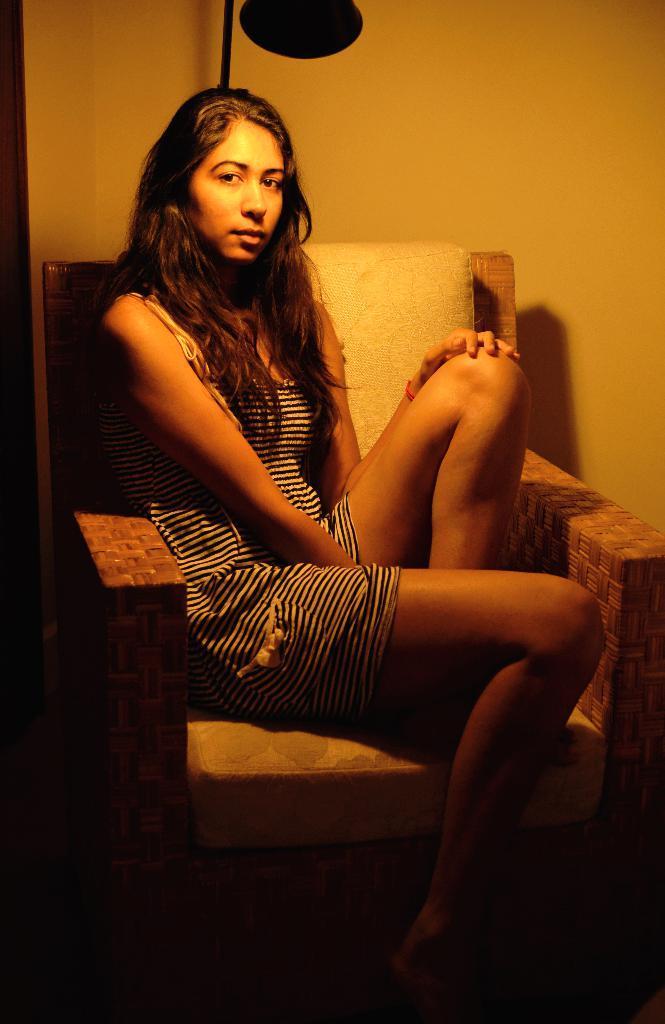Please provide a concise description of this image. This picture shows a woman seated on the chair and we see a light and a wall. 